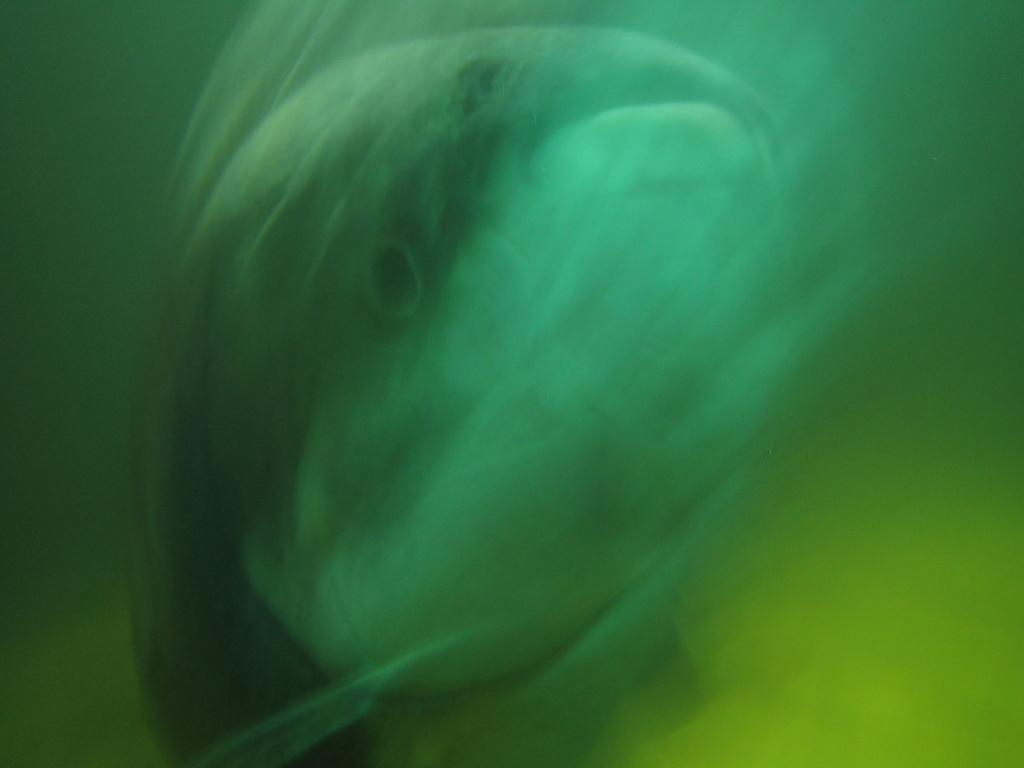What type of animals can be seen in the image? There are fish in the image. Where are the fish located? The fish are in the water. What type of fowl can be seen flying in the image? There is no fowl present in the image; it features fish in the water. What role does friction play in the movement of the fish in the image? The provided facts do not mention friction or its role in the movement of the fish in the image. 